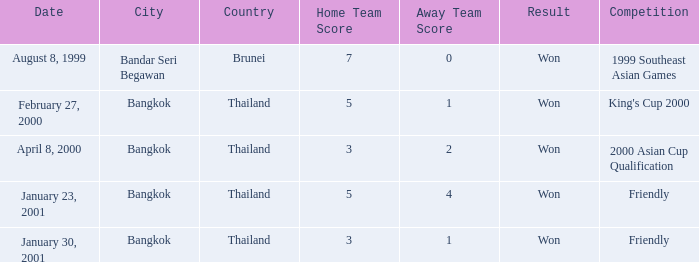During what competition was a game played with a score of 3–1? Friendly. Could you help me parse every detail presented in this table? {'header': ['Date', 'City', 'Country', 'Home Team Score', 'Away Team Score', 'Result', 'Competition'], 'rows': [['August 8, 1999', 'Bandar Seri Begawan', 'Brunei', '7', '0', 'Won', '1999 Southeast Asian Games'], ['February 27, 2000', 'Bangkok', 'Thailand', '5', '1', 'Won', "King's Cup 2000"], ['April 8, 2000', 'Bangkok', 'Thailand', '3', '2', 'Won', '2000 Asian Cup Qualification'], ['January 23, 2001', 'Bangkok', 'Thailand', '5', '4', 'Won', 'Friendly'], ['January 30, 2001', 'Bangkok', 'Thailand', '3', '1', 'Won', 'Friendly']]} 